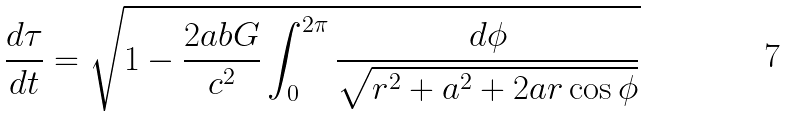Convert formula to latex. <formula><loc_0><loc_0><loc_500><loc_500>\frac { d \tau } { d t } = \sqrt { 1 - \frac { 2 a b G } { c ^ { 2 } } \int _ { 0 } ^ { 2 \pi } \frac { d \phi } { \sqrt { r ^ { 2 } + a ^ { 2 } + 2 a r \cos \phi } } }</formula> 